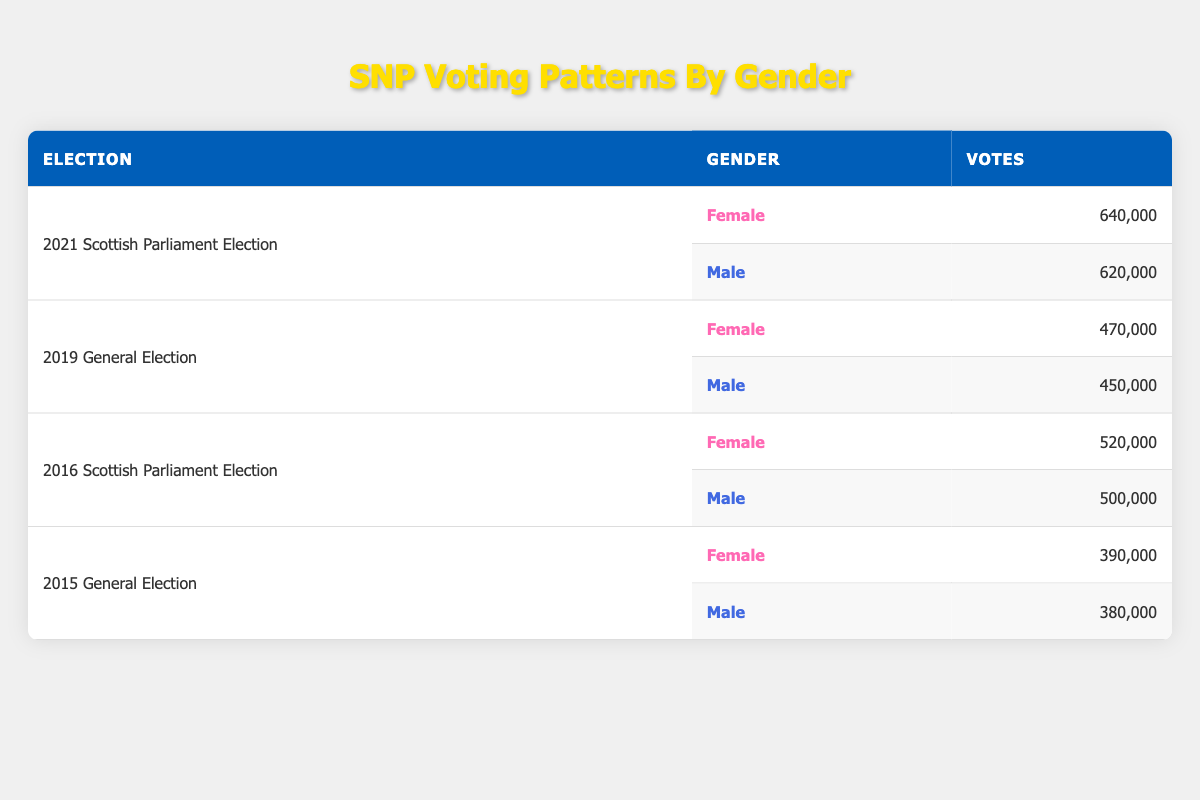What was the total number of votes cast for women in the 2021 Scottish Parliament Election? In the table, for the 2021 Scottish Parliament Election, the votes for women are listed as 640,000.
Answer: 640,000 What was the difference in votes between male and female voters in the 2019 General Election? In the 2019 General Election, males received 450,000 votes and females received 470,000 votes. The difference is calculated by subtracting male votes from female votes: 470,000 - 450,000 = 20,000.
Answer: 20,000 Did men receive more votes than women in the 2015 General Election? The table shows that men received 380,000 votes and women received 390,000 votes in the 2015 General Election. Since 380,000 is less than 390,000, the answer is no.
Answer: No What is the total number of votes for males across all elections listed in the table? To find the total votes for males, we sum the votes from all entries: 620,000 (2021) + 450,000 (2019) + 500,000 (2016) + 380,000 (2015) = 1,950,000.
Answer: 1,950,000 Which election had the highest number of female votes? Looking at the table, the highest number of female votes is in the 2021 Scottish Parliament Election with 640,000 votes.
Answer: 2021 Scottish Parliament Election What election showed the lowest number of votes for male voters? The votes for males were 620,000 in 2021, 450,000 in 2019, 500,000 in 2016, and 380,000 in 2015. The lowest quantity is 380,000 from the 2015 General Election, which means it had the fewest male votes.
Answer: 2015 General Election What is the average number of votes for women across the four elections? To find the average votes for women, sum their votes: 640,000 + 470,000 + 520,000 + 390,000 = 2,020,000. Then, divide this by the number of elections (4): 2,020,000 / 4 = 505,000.
Answer: 505,000 In which election did females have more votes than males? Analyzing the table, in 2021 Scottish Parliament Election (640,000 vs 620,000) and in 2019 General Election (470,000 vs 450,000), females had more votes than males in both these elections.
Answer: Yes, in 2021 Scottish Parliament and 2019 General Election 